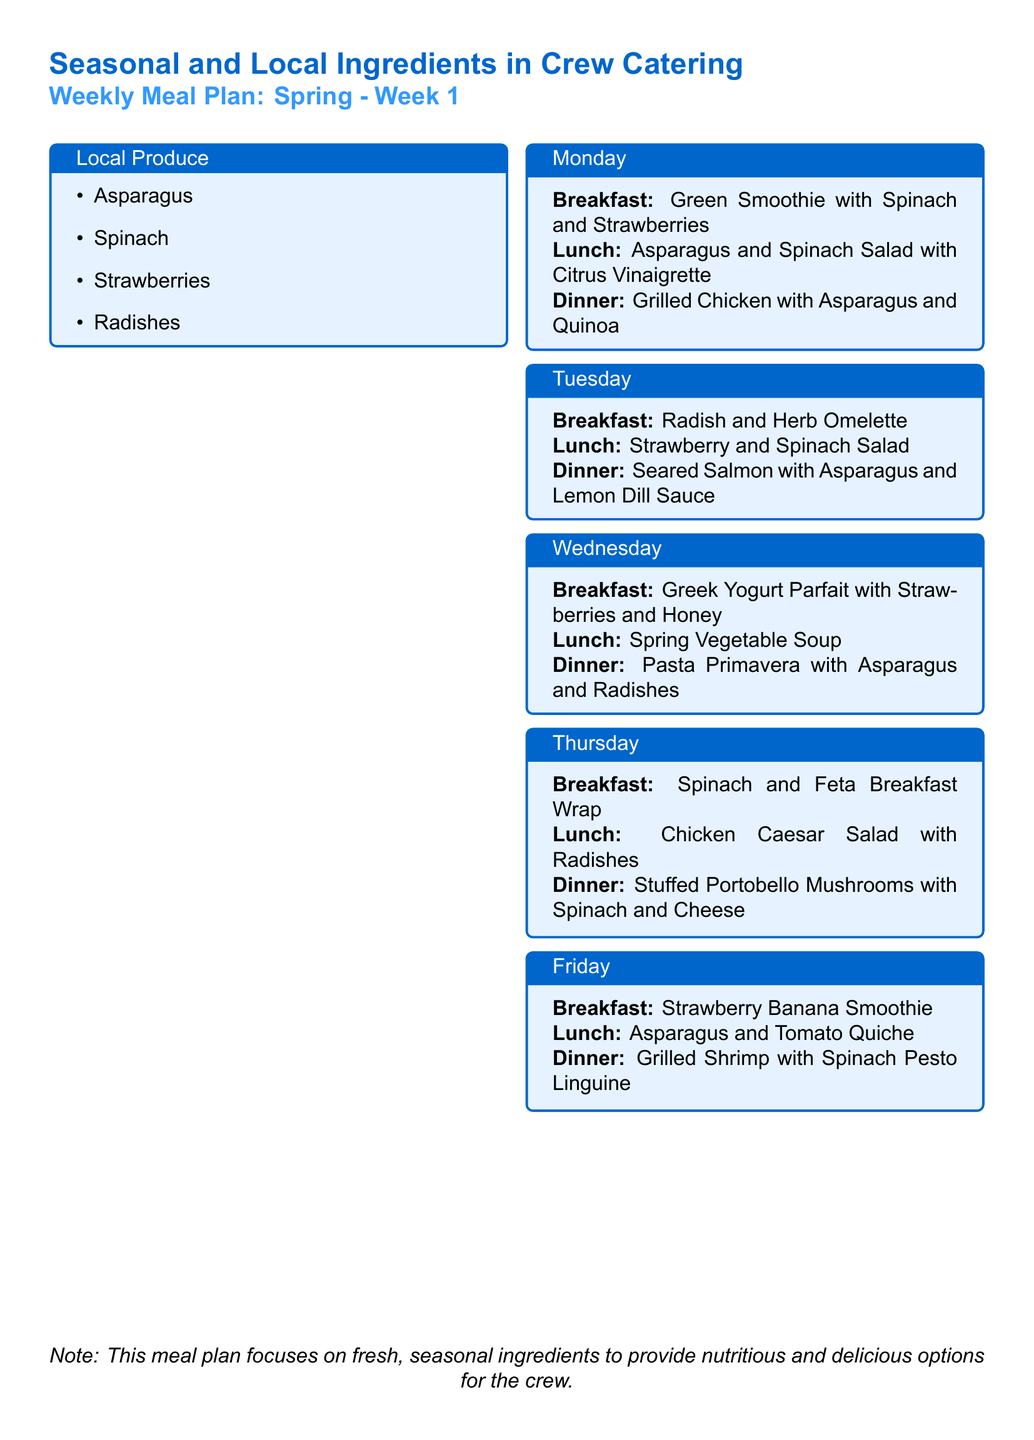What are the local produce items listed for the week? The local produce items are listed in the designated section, which includes Asparagus, Spinach, Strawberries, and Radishes.
Answer: Asparagus, Spinach, Strawberries, Radishes What is served for breakfast on Tuesday? The breakfast menu for Tuesday is presented in the daily section, identifying Radish and Herb Omelette.
Answer: Radish and Herb Omelette Which dinner includes mushrooms? The dinner section for Thursday specifies Stuffed Portobello Mushrooms with Spinach and Cheese as the dish.
Answer: Stuffed Portobello Mushrooms with Spinach and Cheese How many days are meal options provided for? The document lists the meal plans for each day of the week, indicating that options are provided for 5 days.
Answer: 5 What ingredient is commonly featured in the salad options? Spinach is a recurring ingredient observed in both the Monday and Tuesday lunch salads.
Answer: Spinach What type of soup is on the menu for Wednesday lunch? The menu clearly states that Spring Vegetable Soup is served for lunch on Wednesday.
Answer: Spring Vegetable Soup How does the document emphasize ingredient choice? The document notes that the focus is on fresh, seasonal ingredients for nutritious and delicious options.
Answer: Fresh, seasonal ingredients What is the main protein choice for Monday dinner? The dinner for Monday lists Grilled Chicken as the main protein choice in the meal.
Answer: Grilled Chicken 